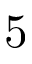<formula> <loc_0><loc_0><loc_500><loc_500>5</formula> 